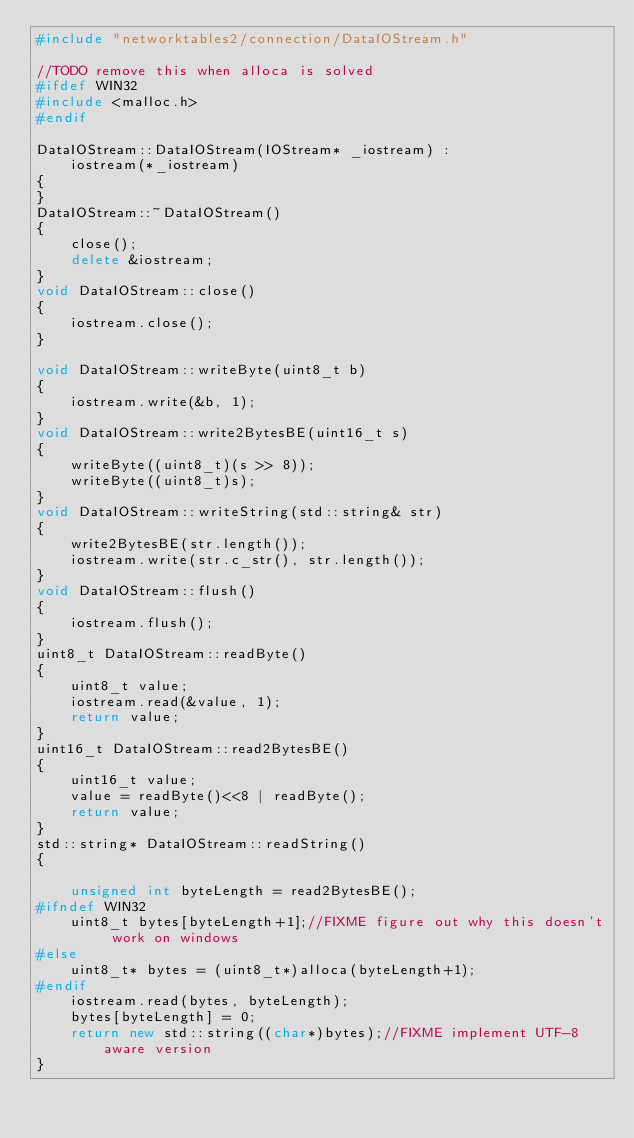<code> <loc_0><loc_0><loc_500><loc_500><_C++_>#include "networktables2/connection/DataIOStream.h"

//TODO remove this when alloca is solved
#ifdef WIN32
#include <malloc.h>
#endif

DataIOStream::DataIOStream(IOStream* _iostream) :
	iostream(*_iostream)
{
}
DataIOStream::~DataIOStream()
{
	close();
	delete &iostream;
}
void DataIOStream::close()
{
	iostream.close();
}

void DataIOStream::writeByte(uint8_t b)
{
	iostream.write(&b, 1);
}
void DataIOStream::write2BytesBE(uint16_t s)
{
	writeByte((uint8_t)(s >> 8));
	writeByte((uint8_t)s);
}
void DataIOStream::writeString(std::string& str)
{
	write2BytesBE(str.length());
	iostream.write(str.c_str(), str.length());
}
void DataIOStream::flush()
{
	iostream.flush();
}
uint8_t DataIOStream::readByte()
{
	uint8_t value;
	iostream.read(&value, 1);
	return value;
}
uint16_t DataIOStream::read2BytesBE()
{
	uint16_t value;
	value = readByte()<<8 | readByte();
	return value;
}
std::string* DataIOStream::readString()
{
	
	unsigned int byteLength = read2BytesBE();
#ifndef WIN32
	uint8_t bytes[byteLength+1];//FIXME figure out why this doesn't work on windows
#else
	uint8_t* bytes = (uint8_t*)alloca(byteLength+1);
#endif
	iostream.read(bytes, byteLength);
	bytes[byteLength] = 0;
	return new std::string((char*)bytes);//FIXME implement UTF-8 aware version
}
</code> 